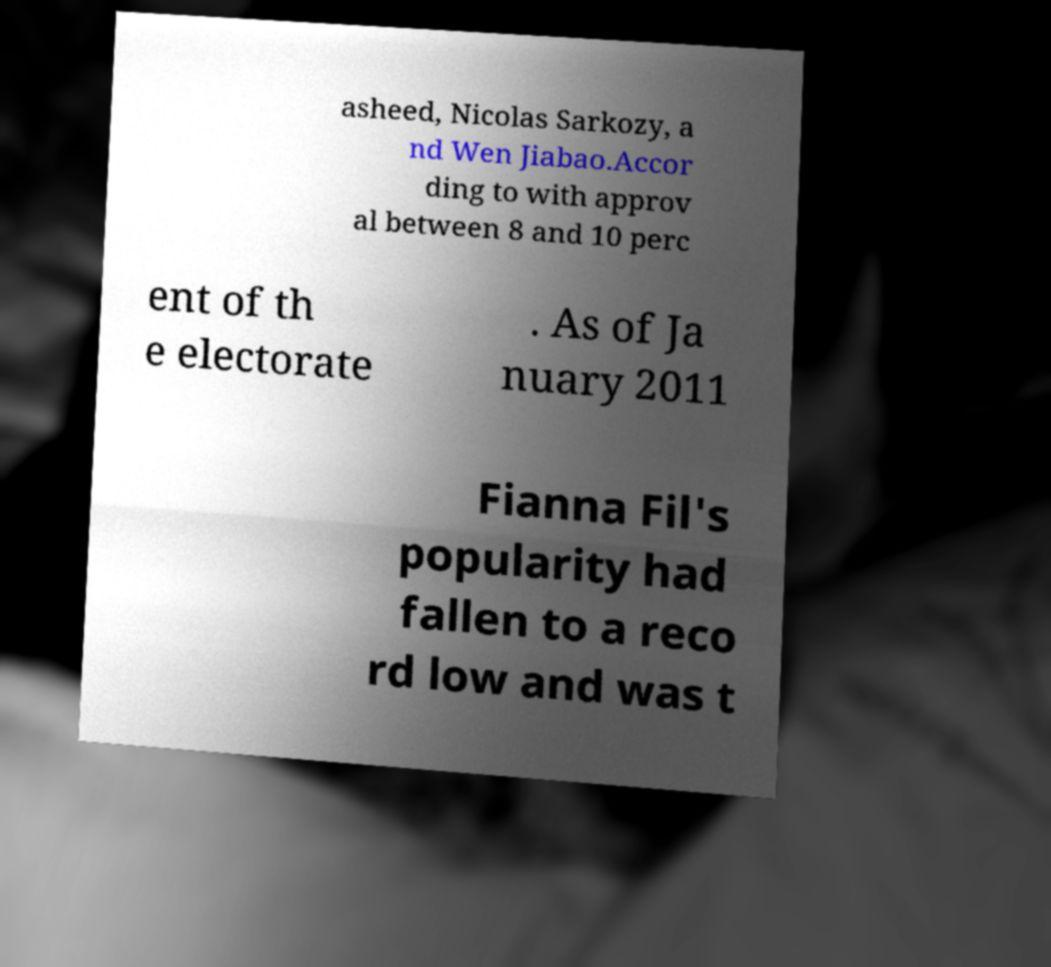I need the written content from this picture converted into text. Can you do that? asheed, Nicolas Sarkozy, a nd Wen Jiabao.Accor ding to with approv al between 8 and 10 perc ent of th e electorate . As of Ja nuary 2011 Fianna Fil's popularity had fallen to a reco rd low and was t 